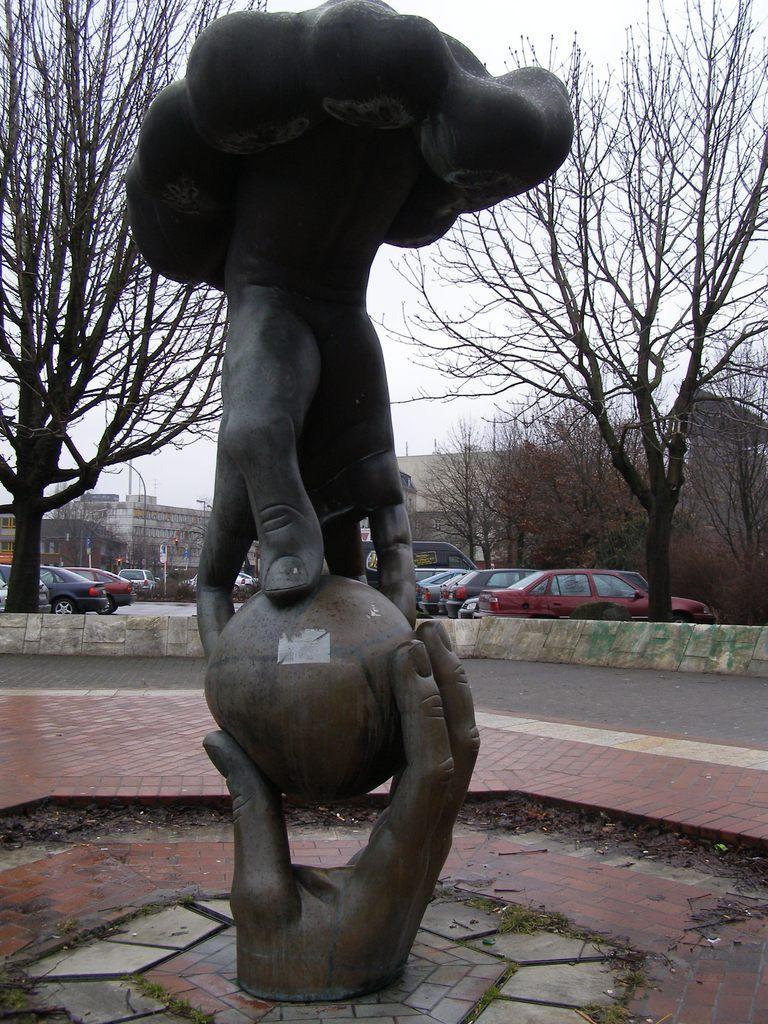In one or two sentences, can you explain what this image depicts? In this picture we can see a statue. Behind the statue, there are trees, buildings, poles, a wall and the sky and there are vehicles on the road. 